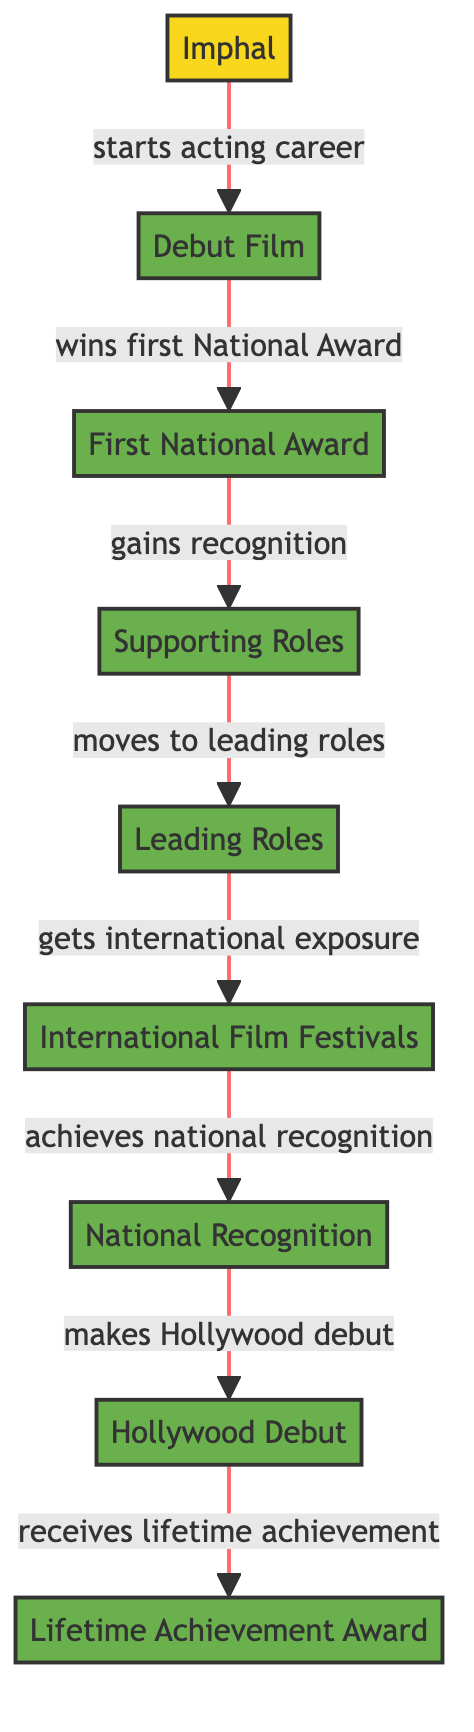What is the starting point of the career progression? The starting point is represented by the node "Imphal," indicating where the actors begin their acting career.
Answer: Imphal How many nodes are present in the diagram? The diagram includes 9 nodes, which represent locations and milestones in the career progression of the actors.
Answer: 9 Which milestone comes after winning the first National Award? The milestone that follows the "First National Award" is "Supporting Roles," indicating the next step in the actor's career progression.
Answer: Supporting Roles What is the label of the final milestone in the career progression? The last milestone in the diagram is "Lifetime Achievement Award," indicating a significant recognition after all previous milestones.
Answer: Lifetime Achievement Award What milestone is achieved after getting international exposure? Following "International Film Festivals," the next milestone is "National Recognition," showcasing the culmination of the exposure gained internationally.
Answer: National Recognition How does an actor move from supporting roles to leading roles? The transition from "Supporting Roles" to "Leading Roles" is indicated by the labeled connection, which states that the actor moves to leading roles after gaining recognition.
Answer: moves to leading roles What relationship exists between the Hollywood debut and the lifetime achievement? The relationship is that the actor makes the "Hollywood Debut" before receiving the "Lifetime Achievement Award," showing the sequence of their accomplishments.
Answer: makes Hollywood debut Which milestone indicates international exposure? The milestone that indicates international exposure is "International Film Festivals," reflecting the actor's involvement in a global setting.
Answer: International Film Festivals What is the sequence of the first three milestones in career progression? The sequence starts with "Debut Film," followed by "First National Award," and then "Supporting Roles," denoting the early achievements in the actor's career.
Answer: Debut Film, First National Award, Supporting Roles 